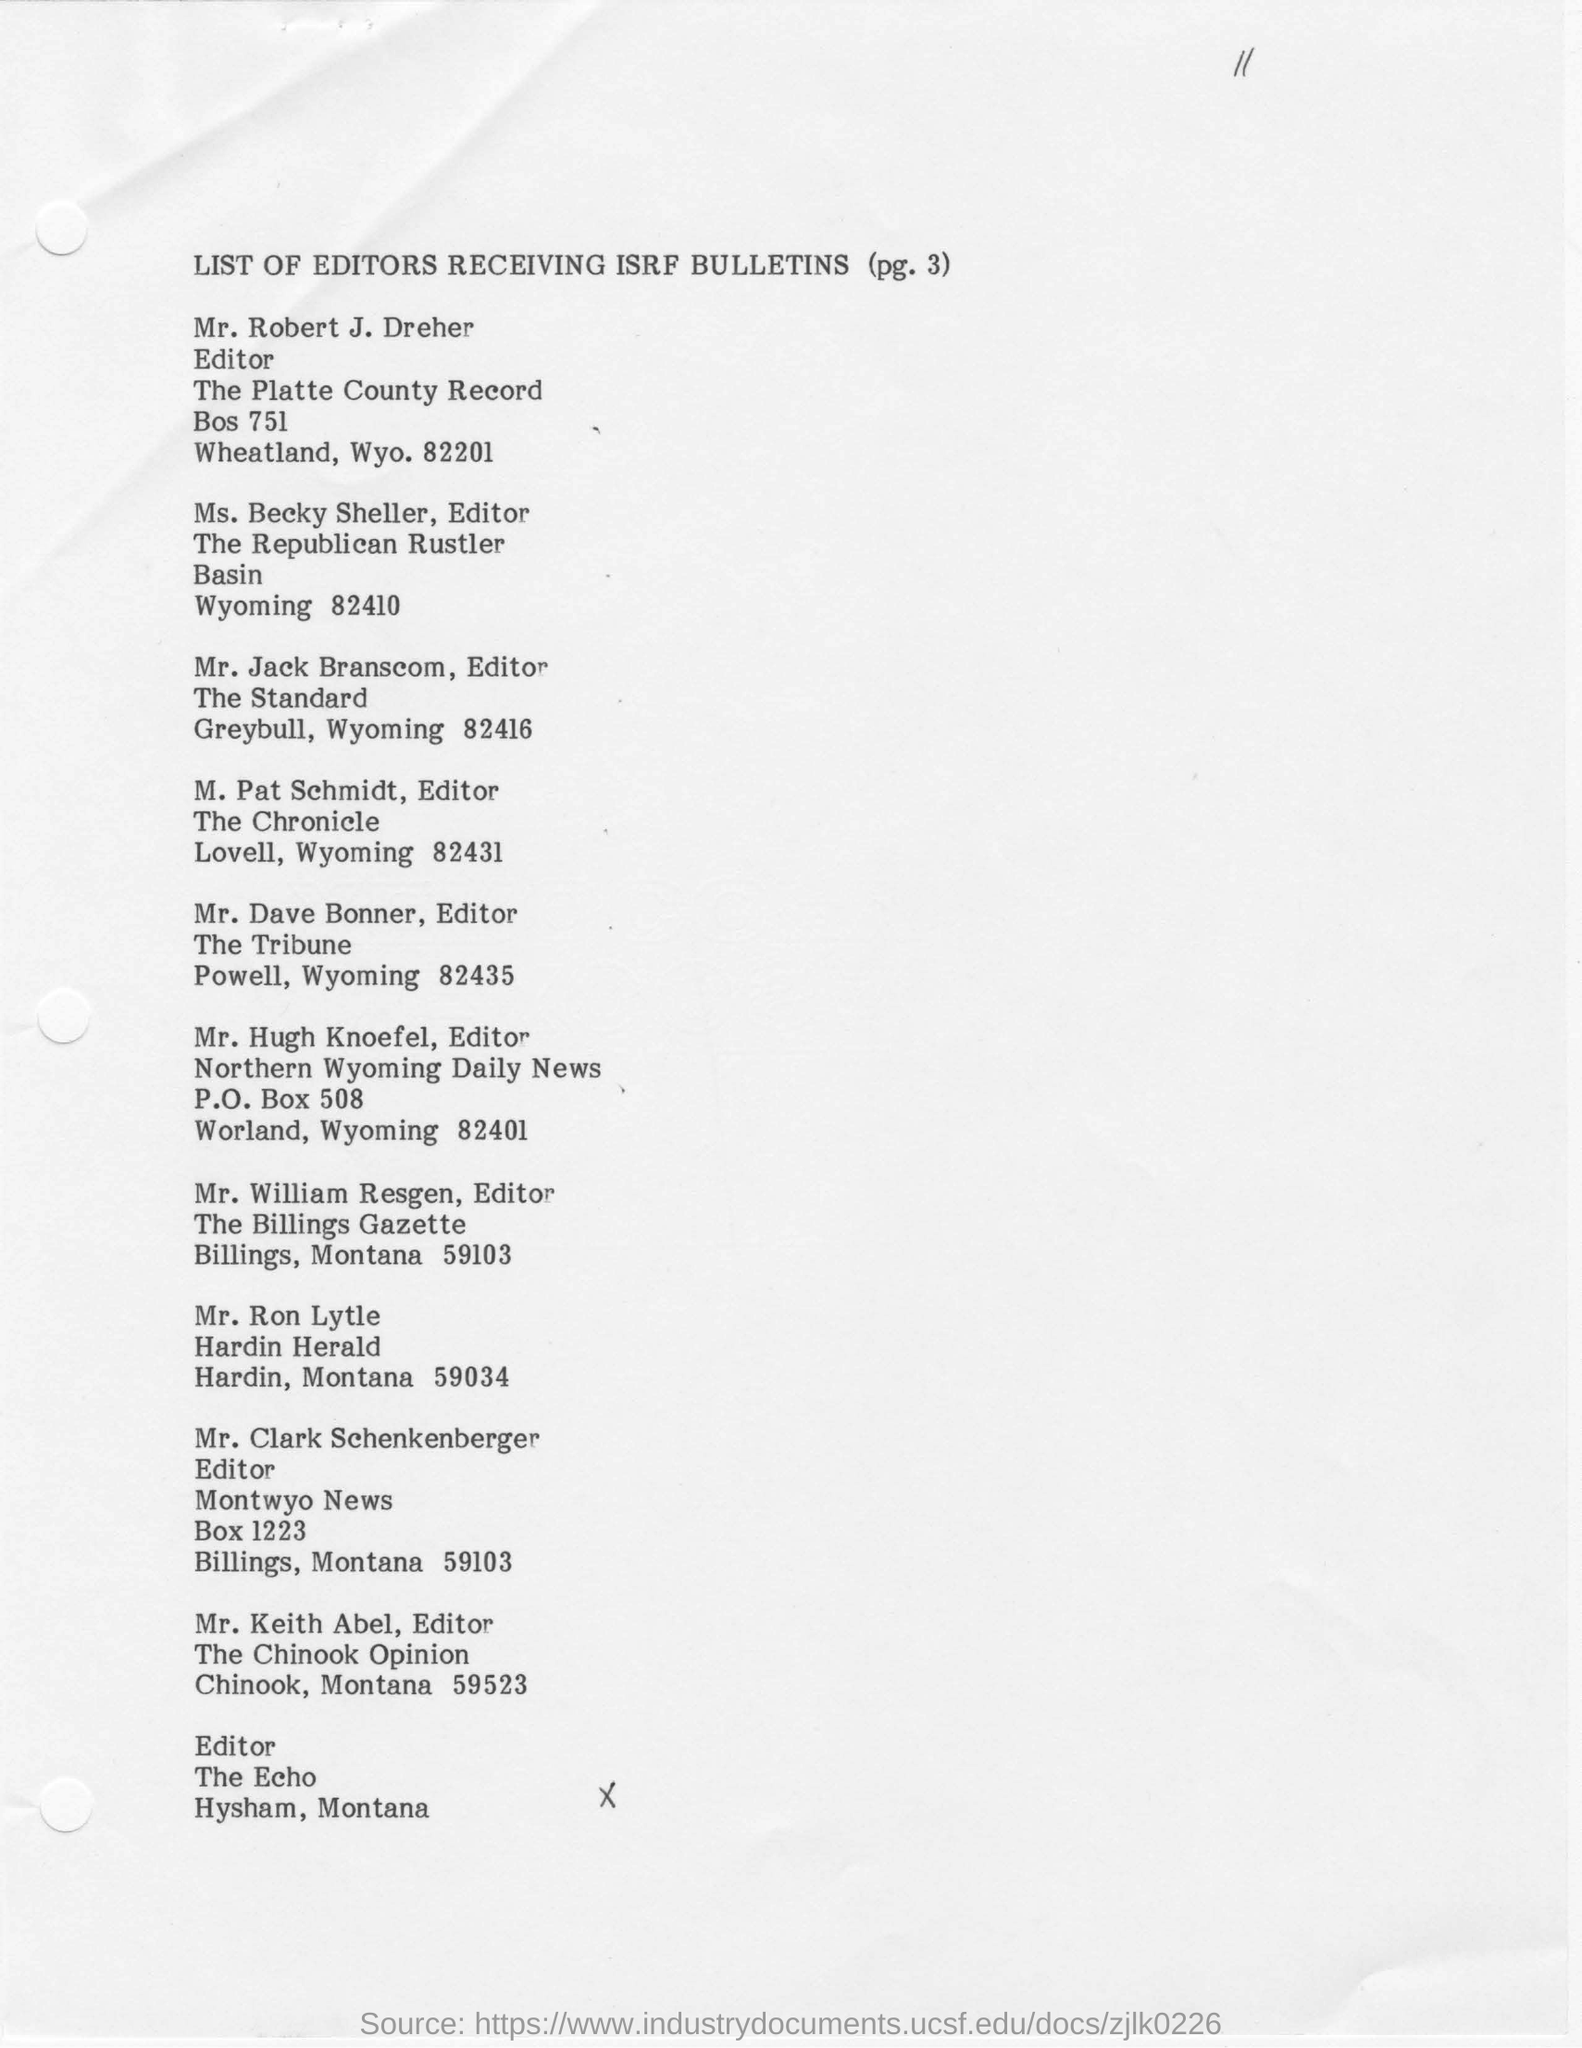Which page is the list of Editors listed?
Make the answer very short. (pg. 3). Who is the Editor for The Chronicle?
Offer a terse response. M. Pat Schmidt. 